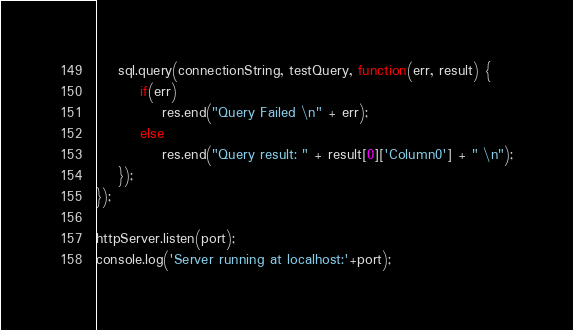<code> <loc_0><loc_0><loc_500><loc_500><_JavaScript_>
	sql.query(connectionString, testQuery, function(err, result) {
		if(err)
			res.end("Query Failed \n" + err);
		else
			res.end("Query result: " + result[0]['Column0'] + " \n");
	});
});

httpServer.listen(port);
console.log('Server running at localhost:'+port);
</code> 